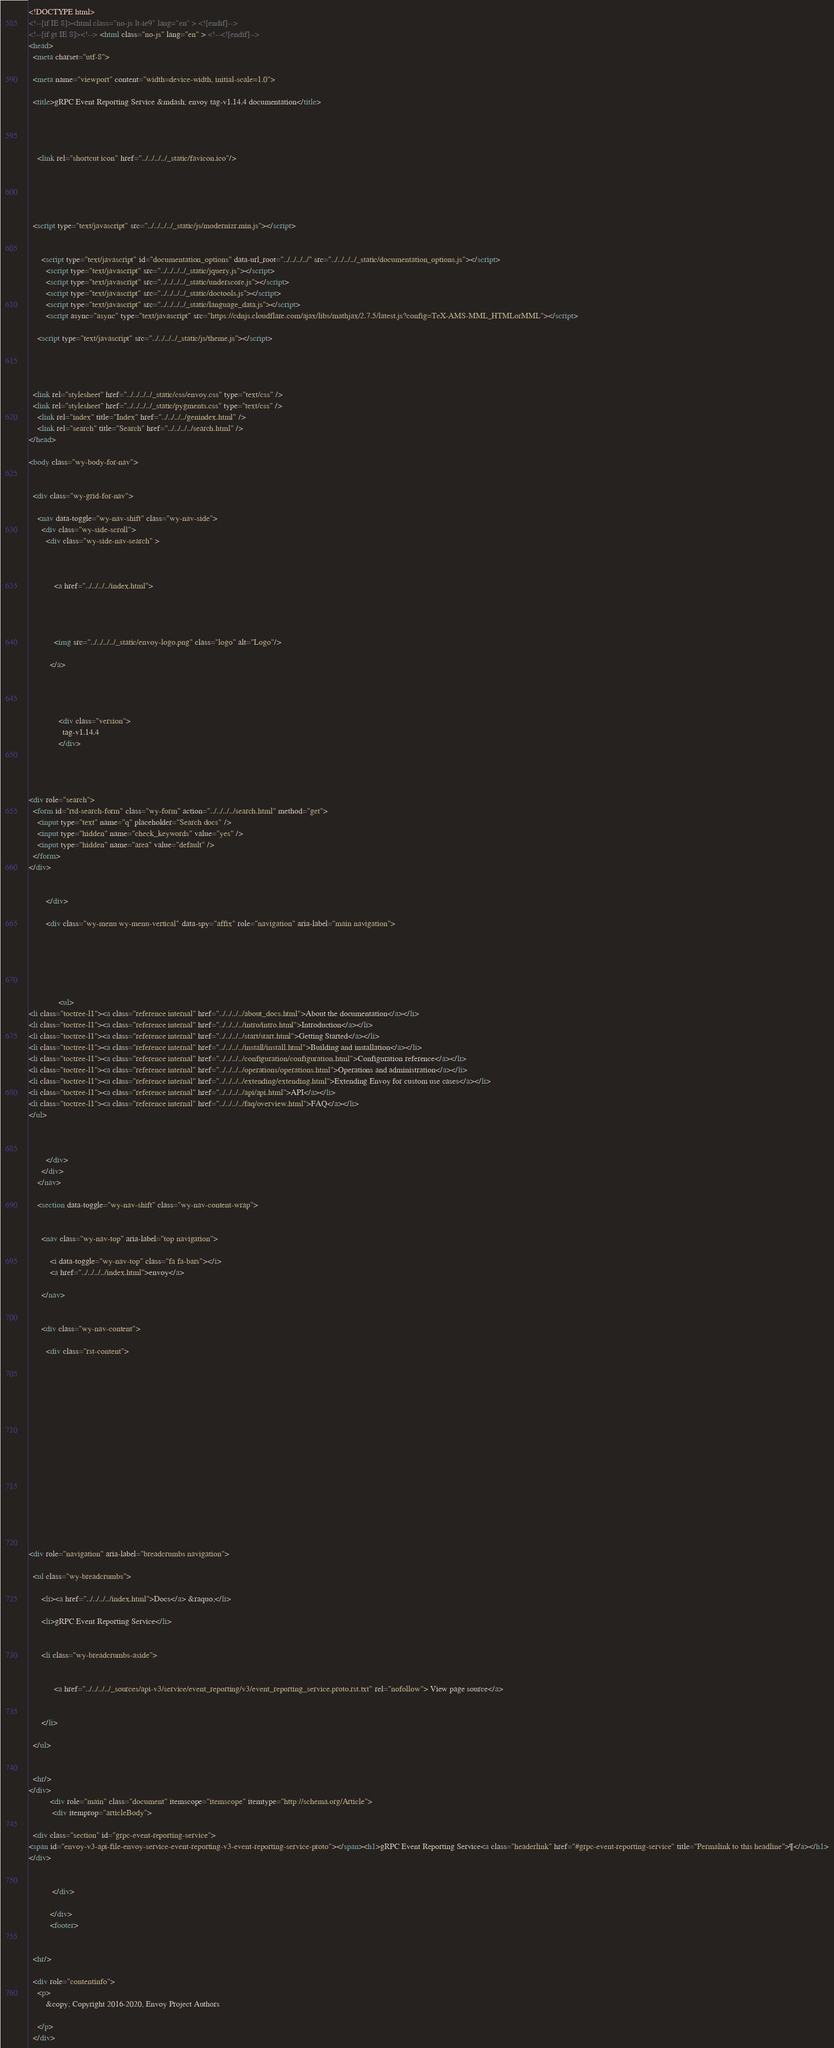<code> <loc_0><loc_0><loc_500><loc_500><_HTML_>

<!DOCTYPE html>
<!--[if IE 8]><html class="no-js lt-ie9" lang="en" > <![endif]-->
<!--[if gt IE 8]><!--> <html class="no-js" lang="en" > <!--<![endif]-->
<head>
  <meta charset="utf-8">
  
  <meta name="viewport" content="width=device-width, initial-scale=1.0">
  
  <title>gRPC Event Reporting Service &mdash; envoy tag-v1.14.4 documentation</title>
  

  
  
    <link rel="shortcut icon" href="../../../../_static/favicon.ico"/>
  
  
  

  
  <script type="text/javascript" src="../../../../_static/js/modernizr.min.js"></script>
  
    
      <script type="text/javascript" id="documentation_options" data-url_root="../../../../" src="../../../../_static/documentation_options.js"></script>
        <script type="text/javascript" src="../../../../_static/jquery.js"></script>
        <script type="text/javascript" src="../../../../_static/underscore.js"></script>
        <script type="text/javascript" src="../../../../_static/doctools.js"></script>
        <script type="text/javascript" src="../../../../_static/language_data.js"></script>
        <script async="async" type="text/javascript" src="https://cdnjs.cloudflare.com/ajax/libs/mathjax/2.7.5/latest.js?config=TeX-AMS-MML_HTMLorMML"></script>
    
    <script type="text/javascript" src="../../../../_static/js/theme.js"></script>

    

  
  <link rel="stylesheet" href="../../../../_static/css/envoy.css" type="text/css" />
  <link rel="stylesheet" href="../../../../_static/pygments.css" type="text/css" />
    <link rel="index" title="Index" href="../../../../genindex.html" />
    <link rel="search" title="Search" href="../../../../search.html" /> 
</head>

<body class="wy-body-for-nav">

   
  <div class="wy-grid-for-nav">
    
    <nav data-toggle="wy-nav-shift" class="wy-nav-side">
      <div class="wy-side-scroll">
        <div class="wy-side-nav-search" >
          

          
            <a href="../../../../index.html">
          

          
            
            <img src="../../../../_static/envoy-logo.png" class="logo" alt="Logo"/>
          
          </a>

          
            
            
              <div class="version">
                tag-v1.14.4
              </div>
            
          

          
<div role="search">
  <form id="rtd-search-form" class="wy-form" action="../../../../search.html" method="get">
    <input type="text" name="q" placeholder="Search docs" />
    <input type="hidden" name="check_keywords" value="yes" />
    <input type="hidden" name="area" value="default" />
  </form>
</div>

          
        </div>

        <div class="wy-menu wy-menu-vertical" data-spy="affix" role="navigation" aria-label="main navigation">
          
            
            
              
            
            
              <ul>
<li class="toctree-l1"><a class="reference internal" href="../../../../about_docs.html">About the documentation</a></li>
<li class="toctree-l1"><a class="reference internal" href="../../../../intro/intro.html">Introduction</a></li>
<li class="toctree-l1"><a class="reference internal" href="../../../../start/start.html">Getting Started</a></li>
<li class="toctree-l1"><a class="reference internal" href="../../../../install/install.html">Building and installation</a></li>
<li class="toctree-l1"><a class="reference internal" href="../../../../configuration/configuration.html">Configuration reference</a></li>
<li class="toctree-l1"><a class="reference internal" href="../../../../operations/operations.html">Operations and administration</a></li>
<li class="toctree-l1"><a class="reference internal" href="../../../../extending/extending.html">Extending Envoy for custom use cases</a></li>
<li class="toctree-l1"><a class="reference internal" href="../../../../api/api.html">API</a></li>
<li class="toctree-l1"><a class="reference internal" href="../../../../faq/overview.html">FAQ</a></li>
</ul>

            
          
        </div>
      </div>
    </nav>

    <section data-toggle="wy-nav-shift" class="wy-nav-content-wrap">

      
      <nav class="wy-nav-top" aria-label="top navigation">
        
          <i data-toggle="wy-nav-top" class="fa fa-bars"></i>
          <a href="../../../../index.html">envoy</a>
        
      </nav>


      <div class="wy-nav-content">
        
        <div class="rst-content">
        
          















<div role="navigation" aria-label="breadcrumbs navigation">

  <ul class="wy-breadcrumbs">
    
      <li><a href="../../../../index.html">Docs</a> &raquo;</li>
        
      <li>gRPC Event Reporting Service</li>
    
    
      <li class="wy-breadcrumbs-aside">
        
            
            <a href="../../../../_sources/api-v3/service/event_reporting/v3/event_reporting_service.proto.rst.txt" rel="nofollow"> View page source</a>
          
        
      </li>
    
  </ul>

  
  <hr/>
</div>
          <div role="main" class="document" itemscope="itemscope" itemtype="http://schema.org/Article">
           <div itemprop="articleBody">
            
  <div class="section" id="grpc-event-reporting-service">
<span id="envoy-v3-api-file-envoy-service-event-reporting-v3-event-reporting-service-proto"></span><h1>gRPC Event Reporting Service<a class="headerlink" href="#grpc-event-reporting-service" title="Permalink to this headline">¶</a></h1>
</div>


           </div>
           
          </div>
          <footer>
  

  <hr/>

  <div role="contentinfo">
    <p>
        &copy; Copyright 2016-2020, Envoy Project Authors

    </p>
  </div></code> 